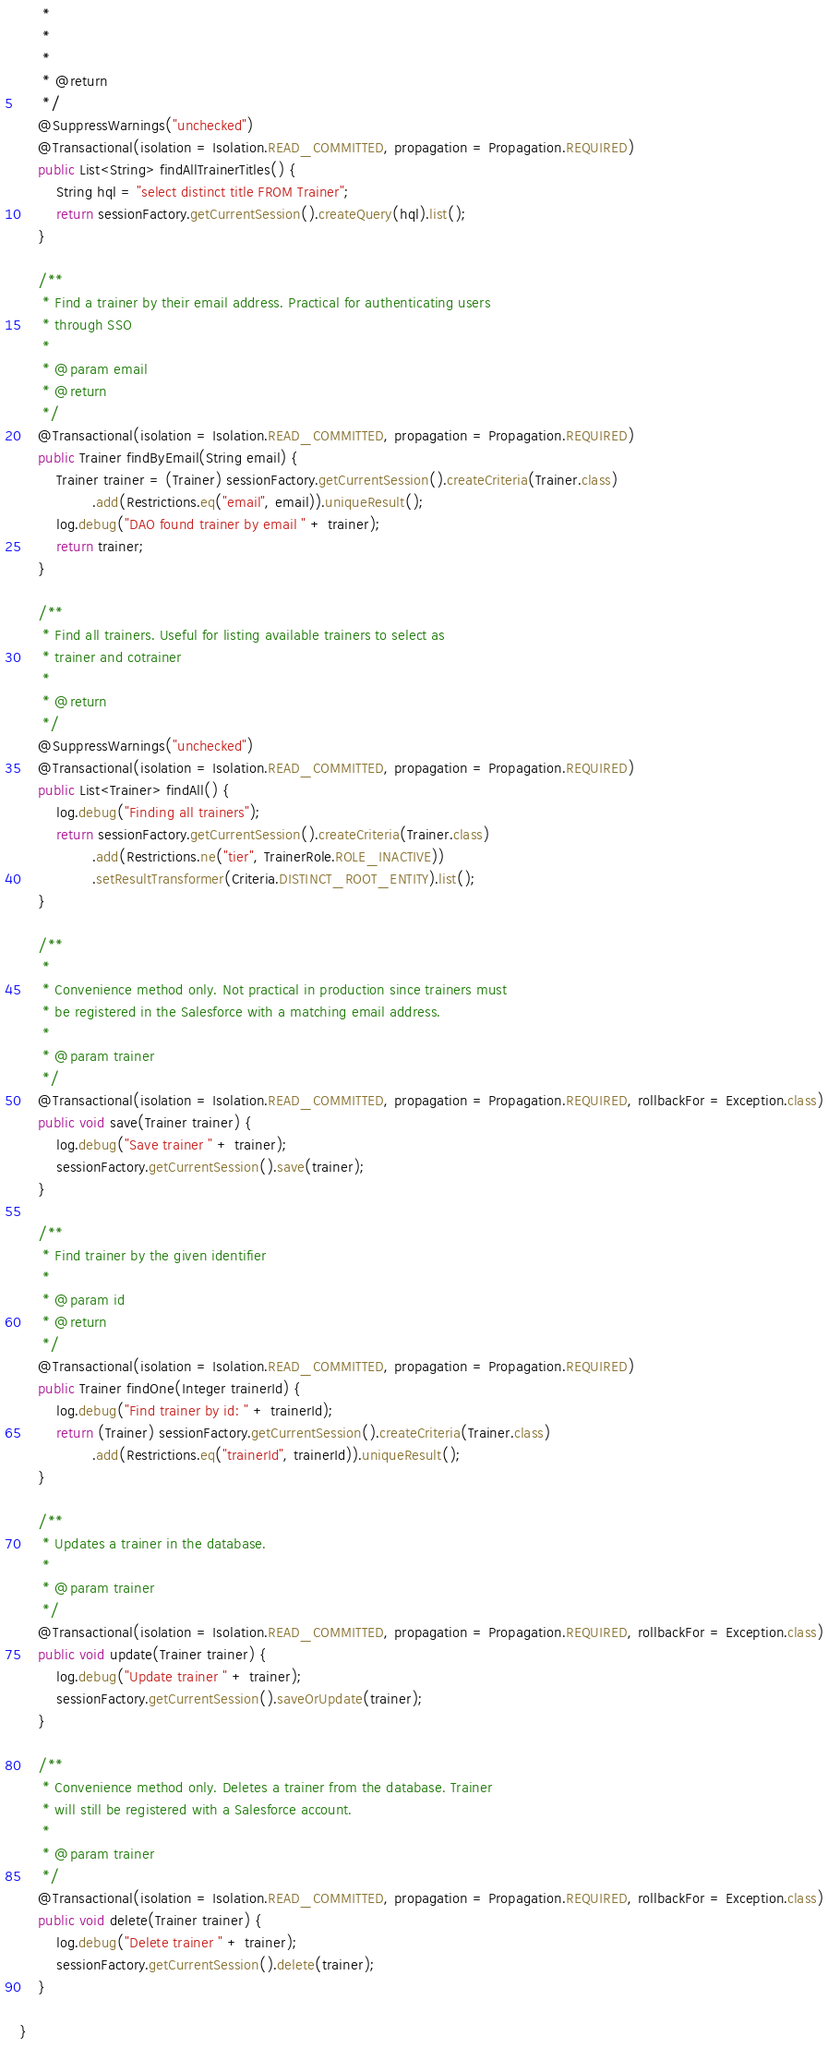Convert code to text. <code><loc_0><loc_0><loc_500><loc_500><_Java_>	 * 
	 * 
	 * 
	 * @return
	 */
	@SuppressWarnings("unchecked")
	@Transactional(isolation = Isolation.READ_COMMITTED, propagation = Propagation.REQUIRED)
	public List<String> findAllTrainerTitles() {
		String hql = "select distinct title FROM Trainer";
		return sessionFactory.getCurrentSession().createQuery(hql).list();
	}

	/**
	 * Find a trainer by their email address. Practical for authenticating users
	 * through SSO
	 * 
	 * @param email
	 * @return
	 */
	@Transactional(isolation = Isolation.READ_COMMITTED, propagation = Propagation.REQUIRED)
	public Trainer findByEmail(String email) {
		Trainer trainer = (Trainer) sessionFactory.getCurrentSession().createCriteria(Trainer.class)
				.add(Restrictions.eq("email", email)).uniqueResult();
		log.debug("DAO found trainer by email " + trainer);
		return trainer;
	}

	/**
	 * Find all trainers. Useful for listing available trainers to select as
	 * trainer and cotrainer
	 * 
	 * @return
	 */
	@SuppressWarnings("unchecked")
	@Transactional(isolation = Isolation.READ_COMMITTED, propagation = Propagation.REQUIRED)
	public List<Trainer> findAll() {
		log.debug("Finding all trainers");
		return sessionFactory.getCurrentSession().createCriteria(Trainer.class)
				.add(Restrictions.ne("tier", TrainerRole.ROLE_INACTIVE))
				.setResultTransformer(Criteria.DISTINCT_ROOT_ENTITY).list();
	}

	/**
	 * 
	 * Convenience method only. Not practical in production since trainers must
	 * be registered in the Salesforce with a matching email address.
	 * 
	 * @param trainer
	 */
	@Transactional(isolation = Isolation.READ_COMMITTED, propagation = Propagation.REQUIRED, rollbackFor = Exception.class)
	public void save(Trainer trainer) {
		log.debug("Save trainer " + trainer);
		sessionFactory.getCurrentSession().save(trainer);
	}

	/**
	 * Find trainer by the given identifier
	 * 
	 * @param id
	 * @return
	 */
	@Transactional(isolation = Isolation.READ_COMMITTED, propagation = Propagation.REQUIRED)
	public Trainer findOne(Integer trainerId) {
		log.debug("Find trainer by id: " + trainerId);
		return (Trainer) sessionFactory.getCurrentSession().createCriteria(Trainer.class)
				.add(Restrictions.eq("trainerId", trainerId)).uniqueResult();
	}

	/**
	 * Updates a trainer in the database.
	 * 
	 * @param trainer
	 */
	@Transactional(isolation = Isolation.READ_COMMITTED, propagation = Propagation.REQUIRED, rollbackFor = Exception.class)
	public void update(Trainer trainer) {
		log.debug("Update trainer " + trainer);
		sessionFactory.getCurrentSession().saveOrUpdate(trainer);
	}

	/**
	 * Convenience method only. Deletes a trainer from the database. Trainer
	 * will still be registered with a Salesforce account.
	 * 
	 * @param trainer
	 */
	@Transactional(isolation = Isolation.READ_COMMITTED, propagation = Propagation.REQUIRED, rollbackFor = Exception.class)
	public void delete(Trainer trainer) {
		log.debug("Delete trainer " + trainer);
		sessionFactory.getCurrentSession().delete(trainer);
	}

}
</code> 